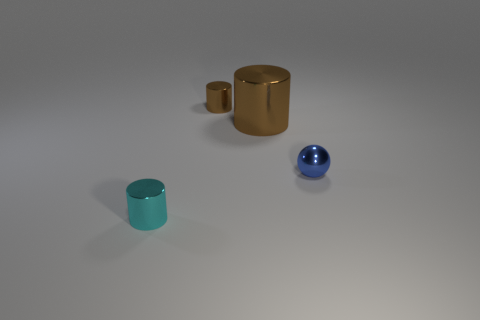What number of other objects are there of the same color as the big shiny object?
Give a very brief answer. 1. Do the cyan cylinder in front of the blue metal object and the small ball have the same size?
Ensure brevity in your answer.  Yes. What number of cylinders are on the left side of the blue shiny thing?
Your answer should be compact. 3. Are there any brown metal cylinders of the same size as the cyan shiny thing?
Your answer should be compact. Yes. Does the small metallic ball have the same color as the big object?
Make the answer very short. No. What color is the tiny metal cylinder that is left of the tiny metal cylinder right of the cyan cylinder?
Keep it short and to the point. Cyan. How many shiny objects are left of the blue shiny ball and in front of the tiny brown shiny cylinder?
Offer a very short reply. 2. What number of blue shiny objects are the same shape as the cyan thing?
Offer a very short reply. 0. Are the cyan thing and the small blue thing made of the same material?
Provide a short and direct response. Yes. What shape is the object that is behind the big cylinder that is left of the tiny metallic sphere?
Offer a very short reply. Cylinder. 